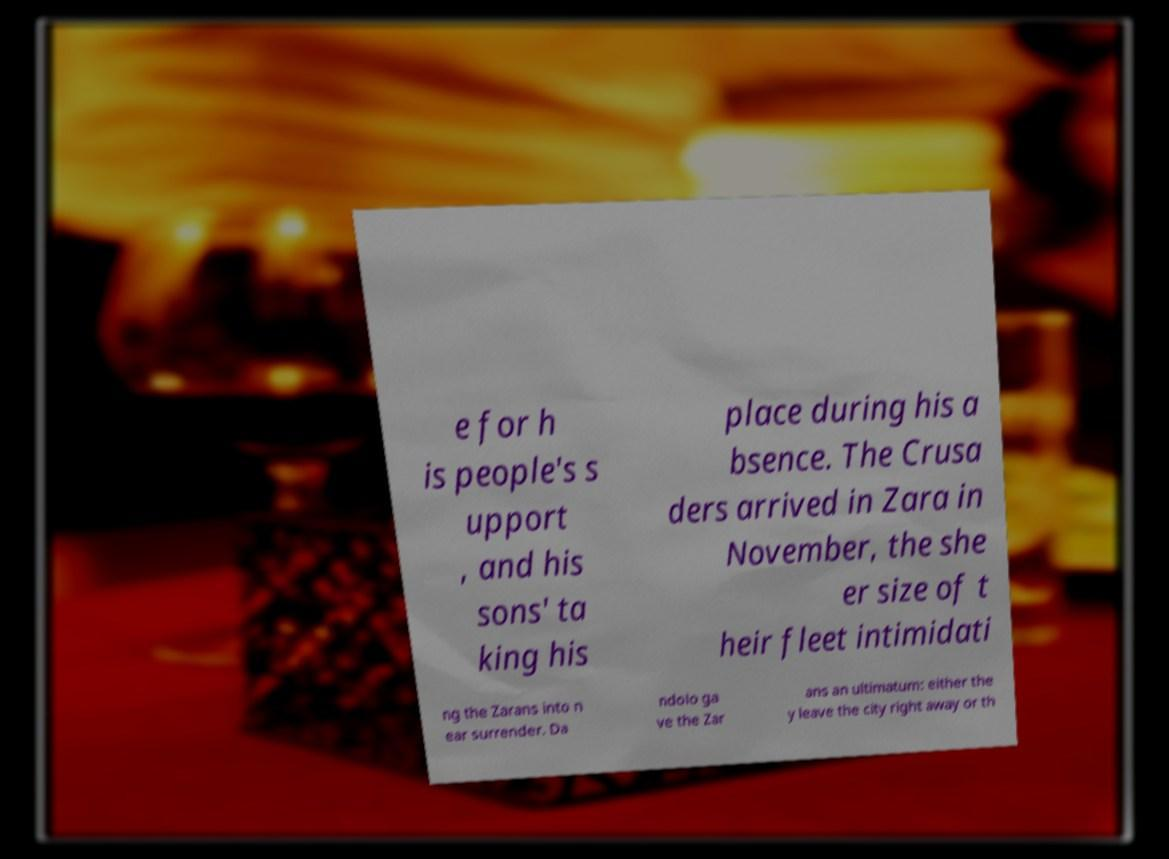Please read and relay the text visible in this image. What does it say? e for h is people's s upport , and his sons' ta king his place during his a bsence. The Crusa ders arrived in Zara in November, the she er size of t heir fleet intimidati ng the Zarans into n ear surrender. Da ndolo ga ve the Zar ans an ultimatum: either the y leave the city right away or th 